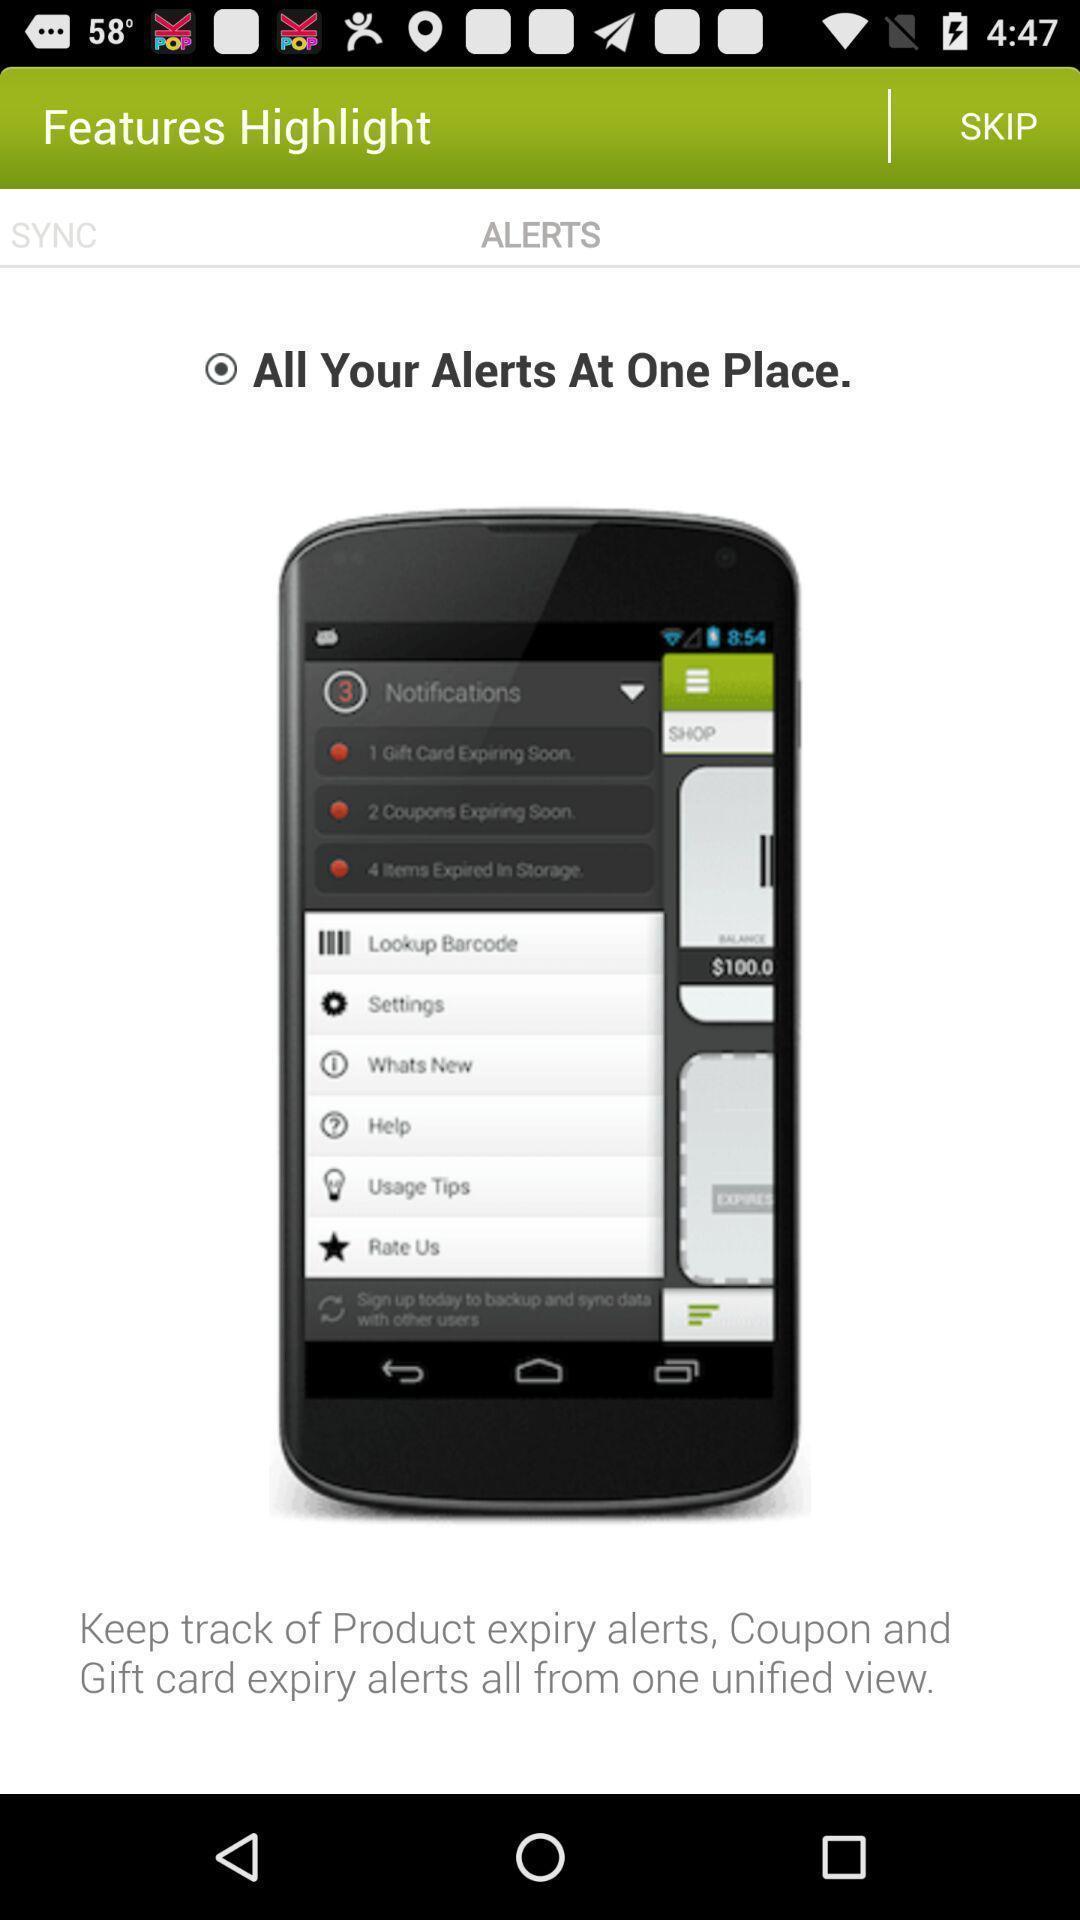What details can you identify in this image? Screen displaying the alert features. 